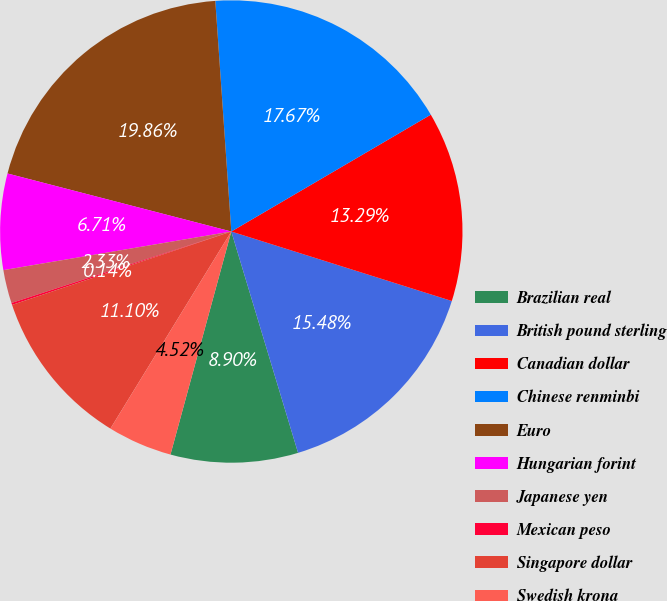<chart> <loc_0><loc_0><loc_500><loc_500><pie_chart><fcel>Brazilian real<fcel>British pound sterling<fcel>Canadian dollar<fcel>Chinese renminbi<fcel>Euro<fcel>Hungarian forint<fcel>Japanese yen<fcel>Mexican peso<fcel>Singapore dollar<fcel>Swedish krona<nl><fcel>8.9%<fcel>15.48%<fcel>13.29%<fcel>17.67%<fcel>19.86%<fcel>6.71%<fcel>2.33%<fcel>0.14%<fcel>11.1%<fcel>4.52%<nl></chart> 